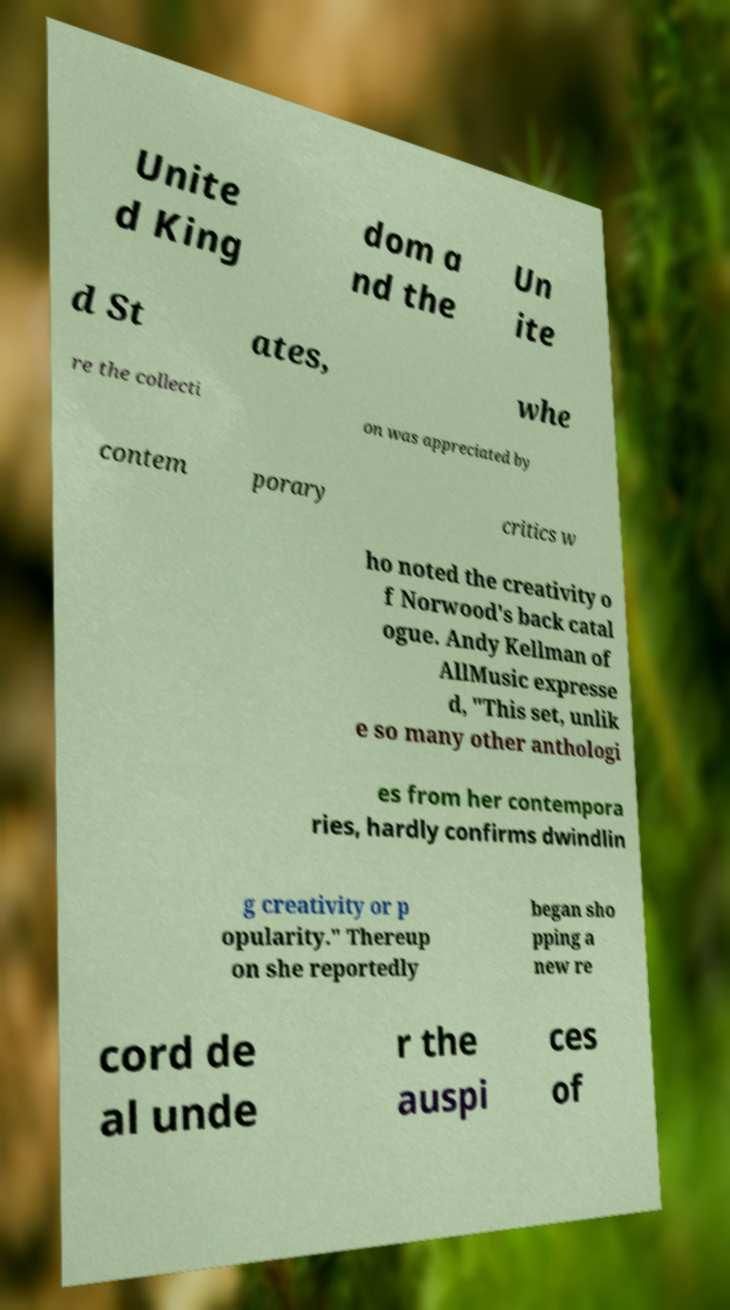Can you read and provide the text displayed in the image?This photo seems to have some interesting text. Can you extract and type it out for me? Unite d King dom a nd the Un ite d St ates, whe re the collecti on was appreciated by contem porary critics w ho noted the creativity o f Norwood's back catal ogue. Andy Kellman of AllMusic expresse d, "This set, unlik e so many other anthologi es from her contempora ries, hardly confirms dwindlin g creativity or p opularity." Thereup on she reportedly began sho pping a new re cord de al unde r the auspi ces of 